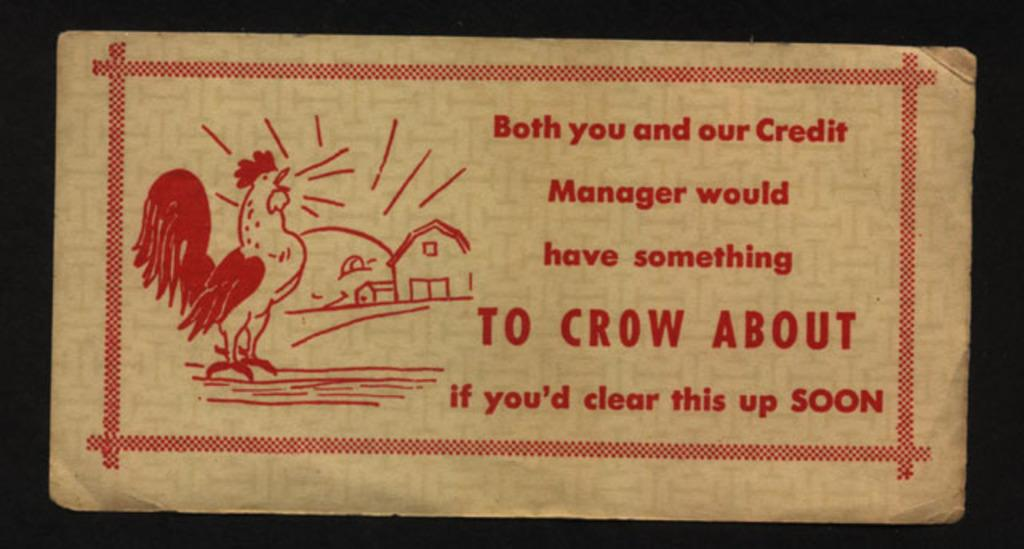What is the main subject of the sketch in the image? The main subject of the sketch in the image is a hen. What type of structures are depicted in the image? There are houses depicted in the image. What is written or displayed on the board in the image? There is text on a board in the image. How would you describe the overall lighting or brightness of the image? The background of the image is dark. What level of difficulty is the hen attempting in the image? The image does not depict a hen attempting a level of difficulty; it is a sketch of a hen. Can you see a tank in the image? There is no tank present in the image. 